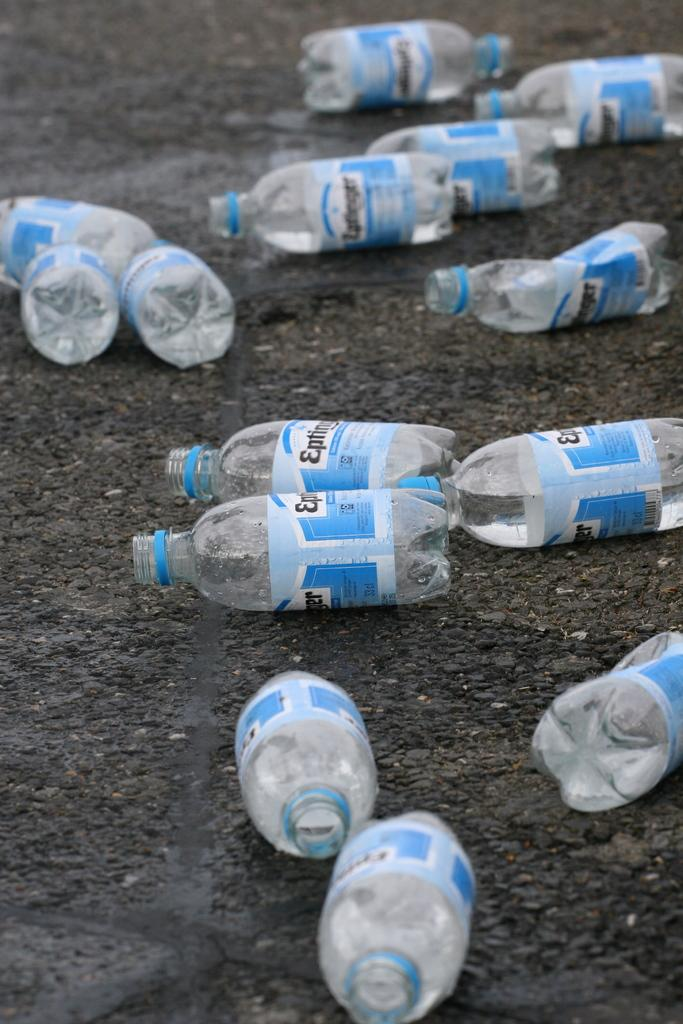<image>
Share a concise interpretation of the image provided. Several blue and white bottles laying on dirt with the word Eptinger on them. 